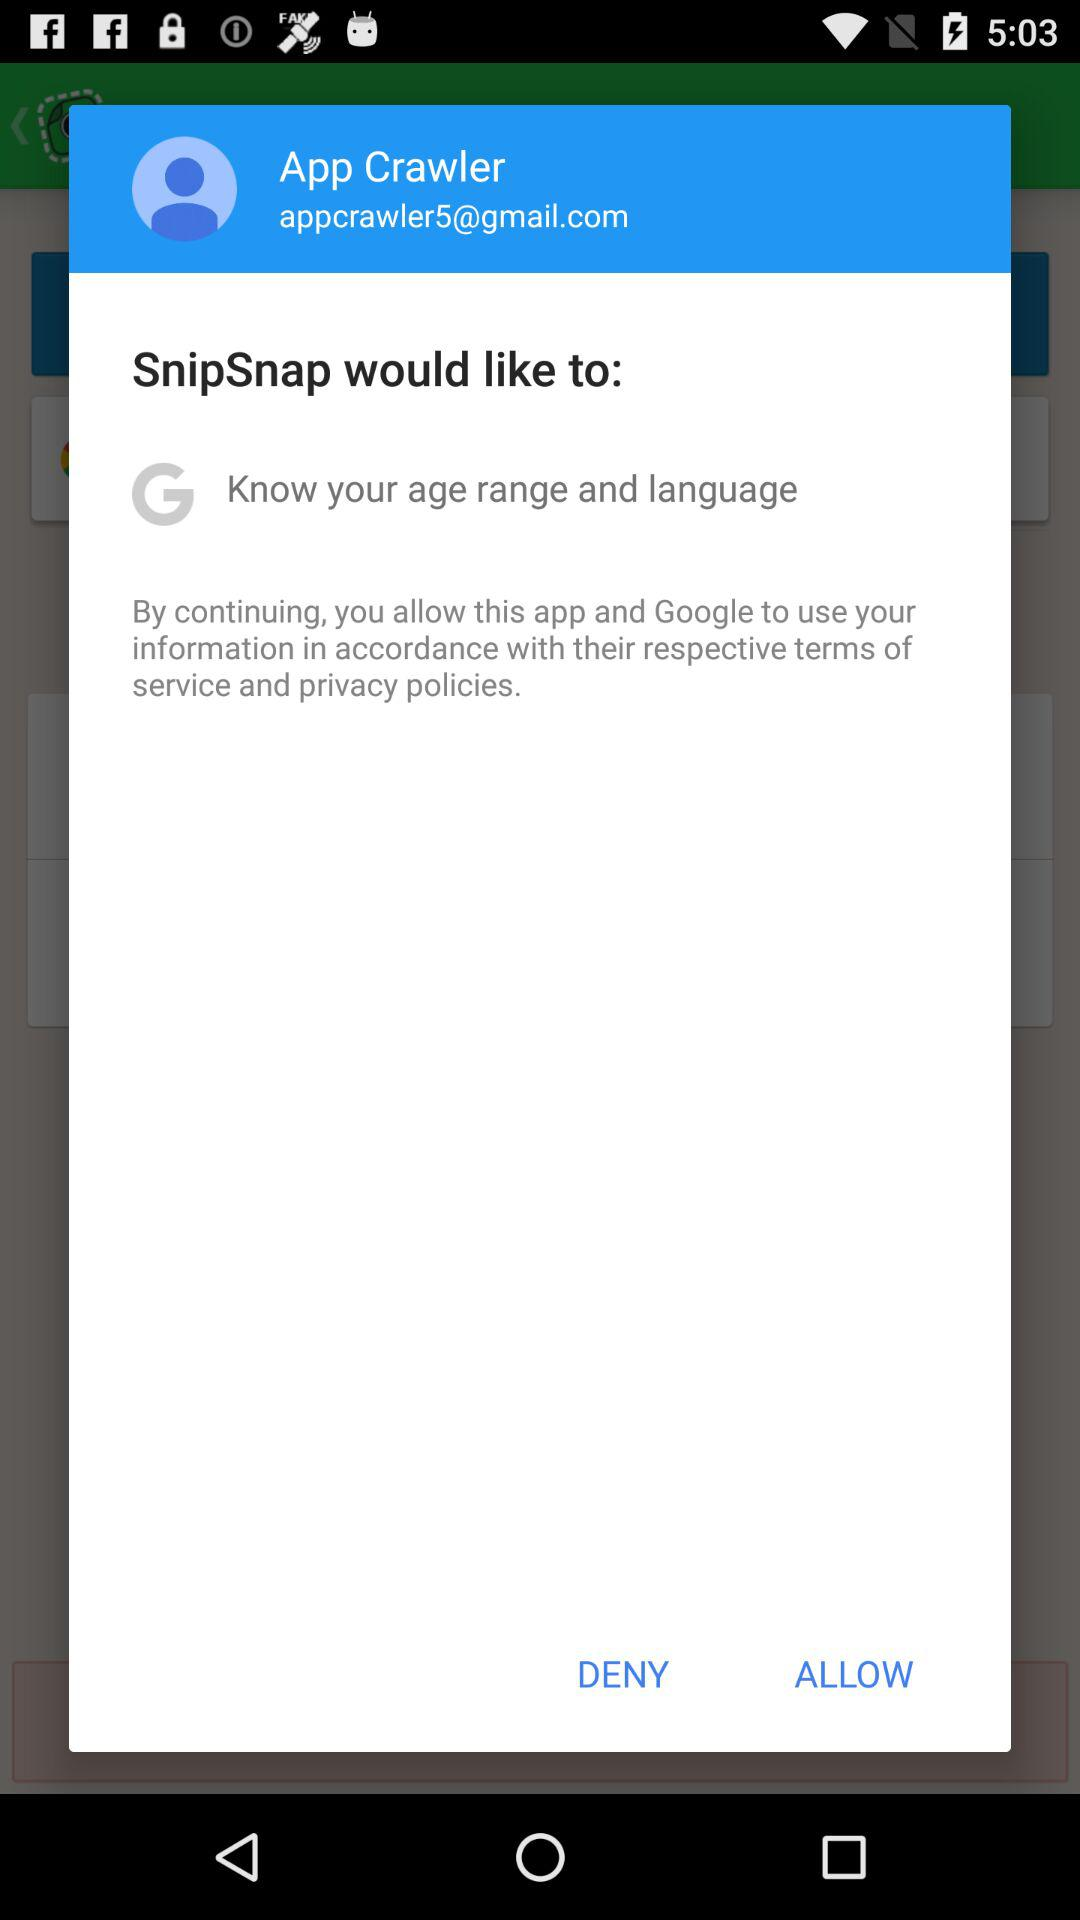What would "SnipSnap" like to know? "SnipSnap" would like to know your age range and language. 